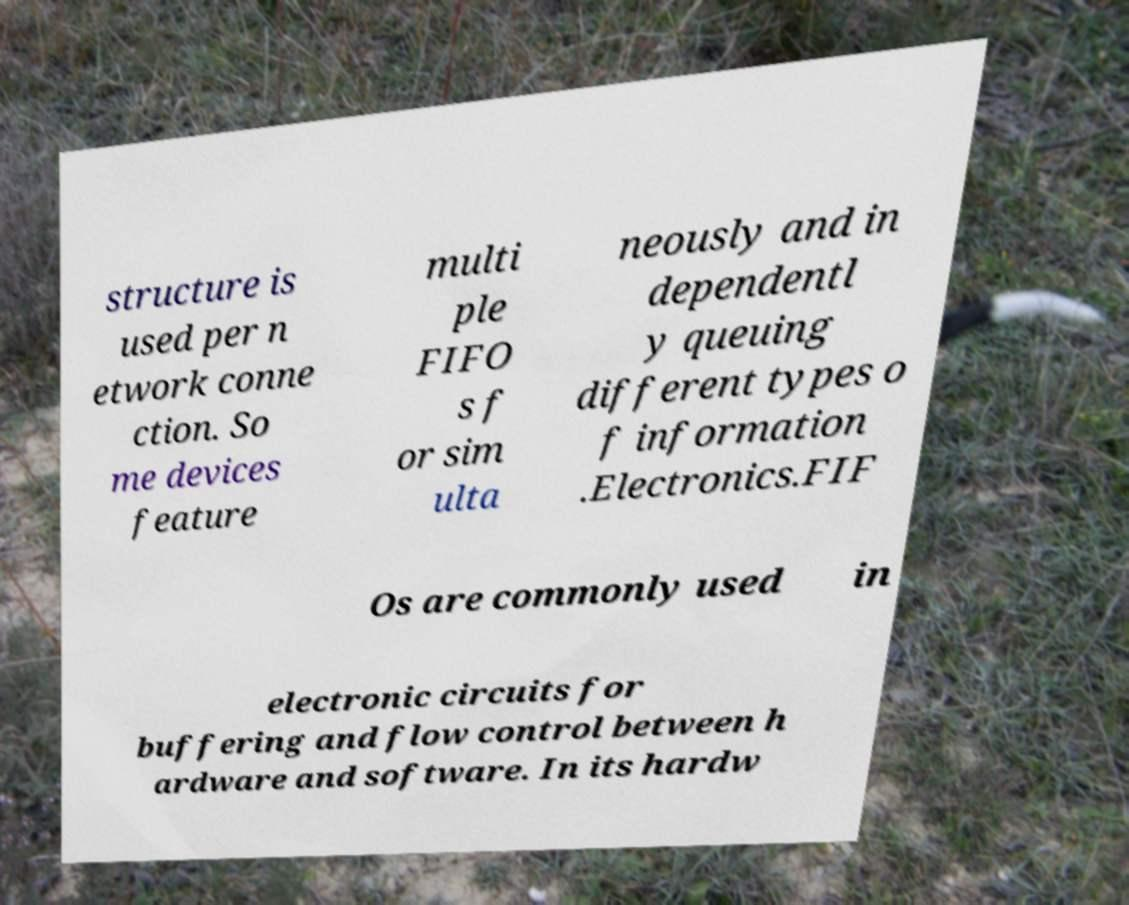Can you read and provide the text displayed in the image?This photo seems to have some interesting text. Can you extract and type it out for me? structure is used per n etwork conne ction. So me devices feature multi ple FIFO s f or sim ulta neously and in dependentl y queuing different types o f information .Electronics.FIF Os are commonly used in electronic circuits for buffering and flow control between h ardware and software. In its hardw 